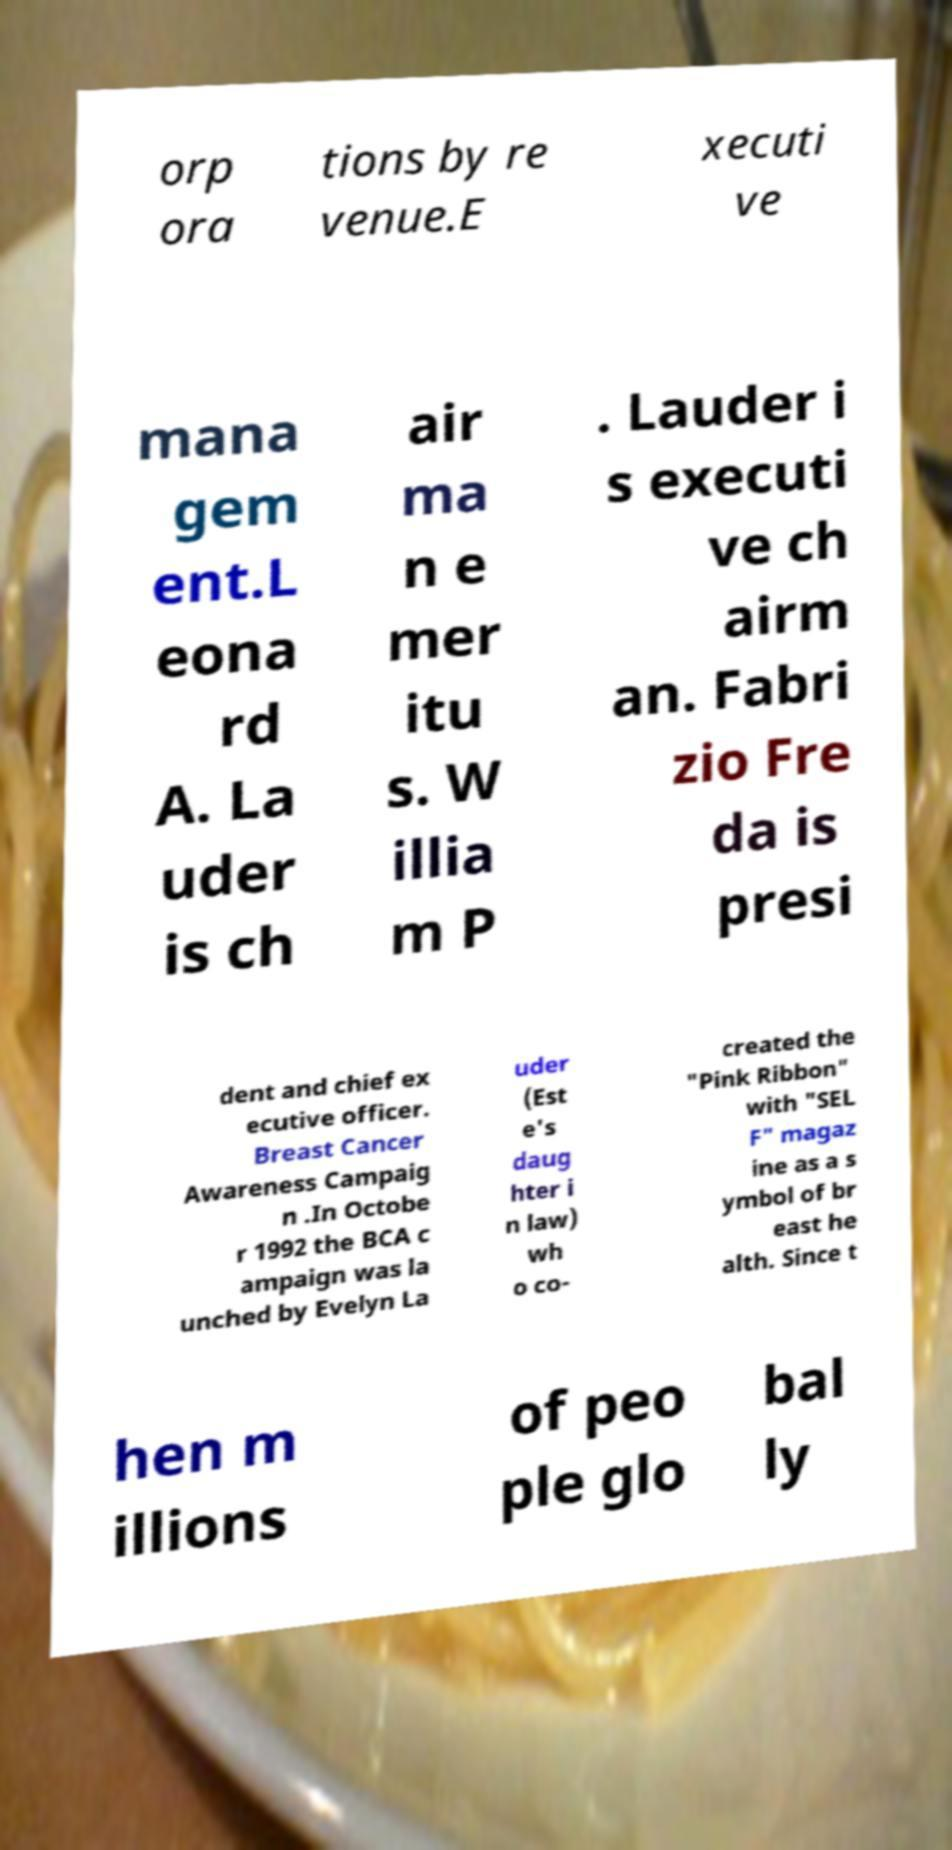There's text embedded in this image that I need extracted. Can you transcribe it verbatim? orp ora tions by re venue.E xecuti ve mana gem ent.L eona rd A. La uder is ch air ma n e mer itu s. W illia m P . Lauder i s executi ve ch airm an. Fabri zio Fre da is presi dent and chief ex ecutive officer. Breast Cancer Awareness Campaig n .In Octobe r 1992 the BCA c ampaign was la unched by Evelyn La uder (Est e's daug hter i n law) wh o co- created the "Pink Ribbon" with "SEL F" magaz ine as a s ymbol of br east he alth. Since t hen m illions of peo ple glo bal ly 